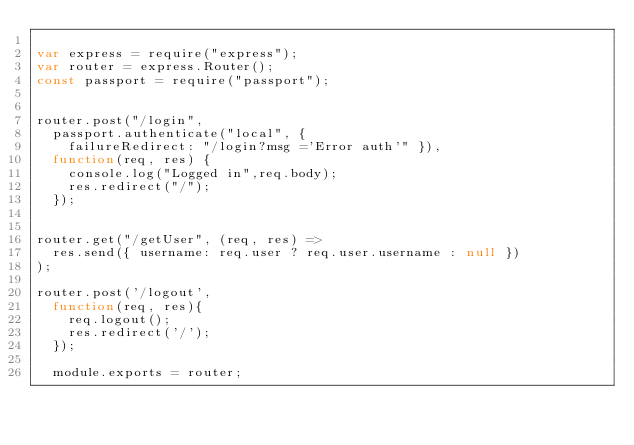<code> <loc_0><loc_0><loc_500><loc_500><_JavaScript_>
var express = require("express");
var router = express.Router();
const passport = require("passport");

  
router.post("/login", 
  passport.authenticate("local", { 
    failureRedirect: "/login?msg ='Error auth'" }),
  function(req, res) {
    console.log("Logged in",req.body);
    res.redirect("/");
  });


router.get("/getUser", (req, res) =>
  res.send({ username: req.user ? req.user.username : null })
);

router.post('/logout',
  function(req, res){
    req.logout();
    res.redirect('/');
  });

  module.exports = router;</code> 